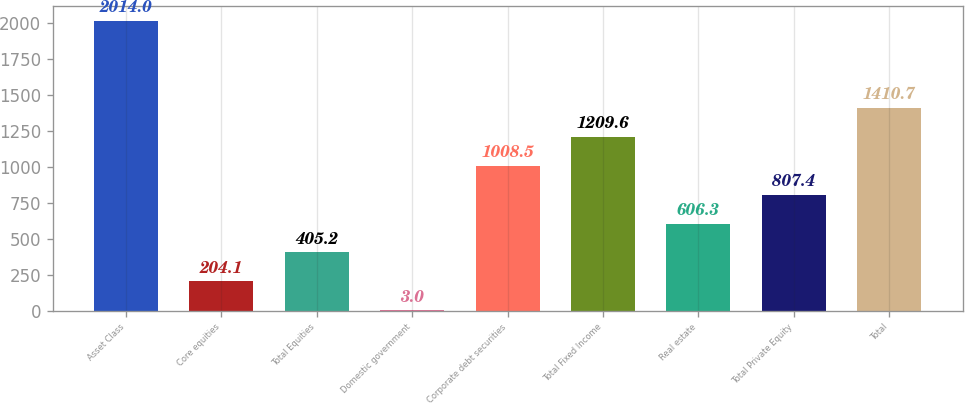Convert chart. <chart><loc_0><loc_0><loc_500><loc_500><bar_chart><fcel>Asset Class<fcel>Core equities<fcel>Total Equities<fcel>Domestic government<fcel>Corporate debt securities<fcel>Total Fixed Income<fcel>Real estate<fcel>Total Private Equity<fcel>Total<nl><fcel>2014<fcel>204.1<fcel>405.2<fcel>3<fcel>1008.5<fcel>1209.6<fcel>606.3<fcel>807.4<fcel>1410.7<nl></chart> 